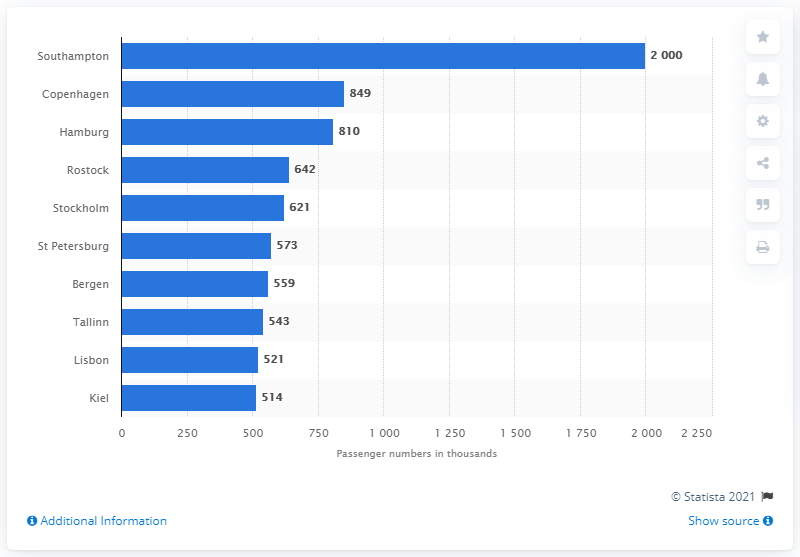Draw attention to some important aspects in this diagram. Copenhagen is the second most popular cruise port in Northern Europe. 